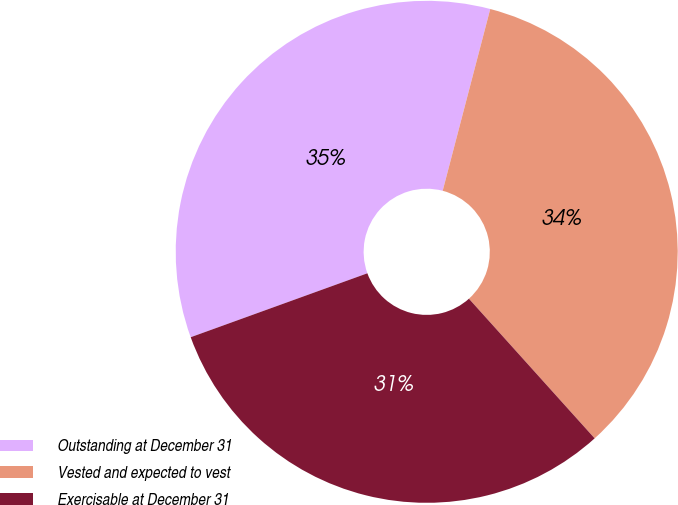Convert chart to OTSL. <chart><loc_0><loc_0><loc_500><loc_500><pie_chart><fcel>Outstanding at December 31<fcel>Vested and expected to vest<fcel>Exercisable at December 31<nl><fcel>34.6%<fcel>34.26%<fcel>31.14%<nl></chart> 